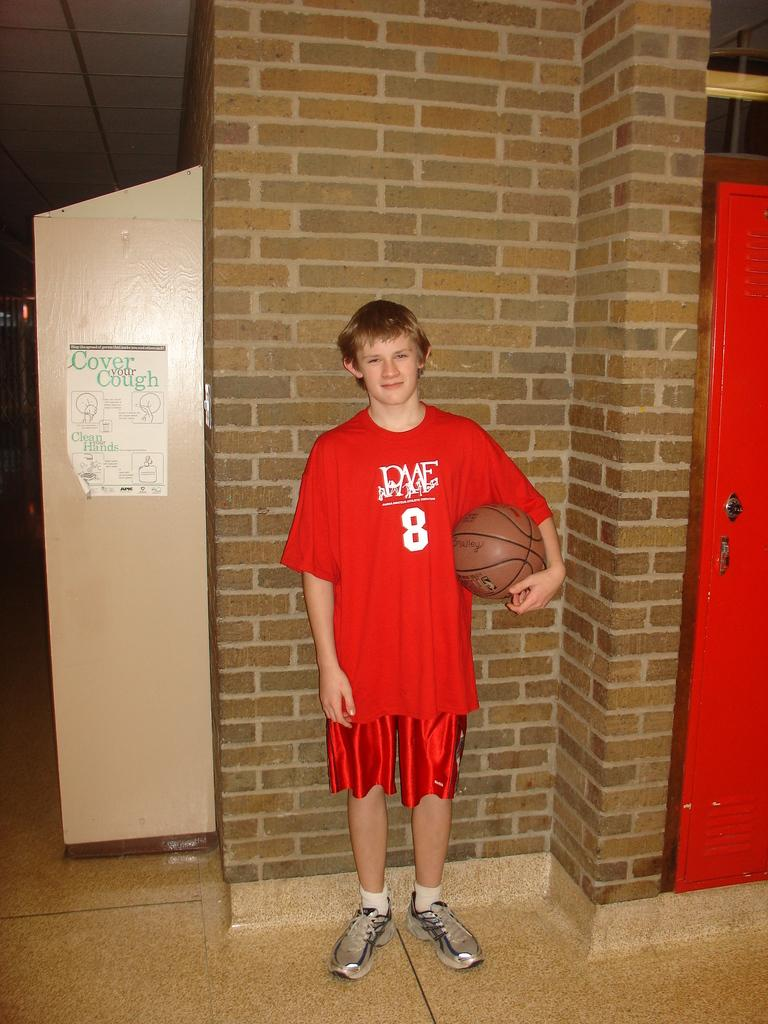<image>
Share a concise interpretation of the image provided. A boy wearing a red shirt with the number 8 on it 